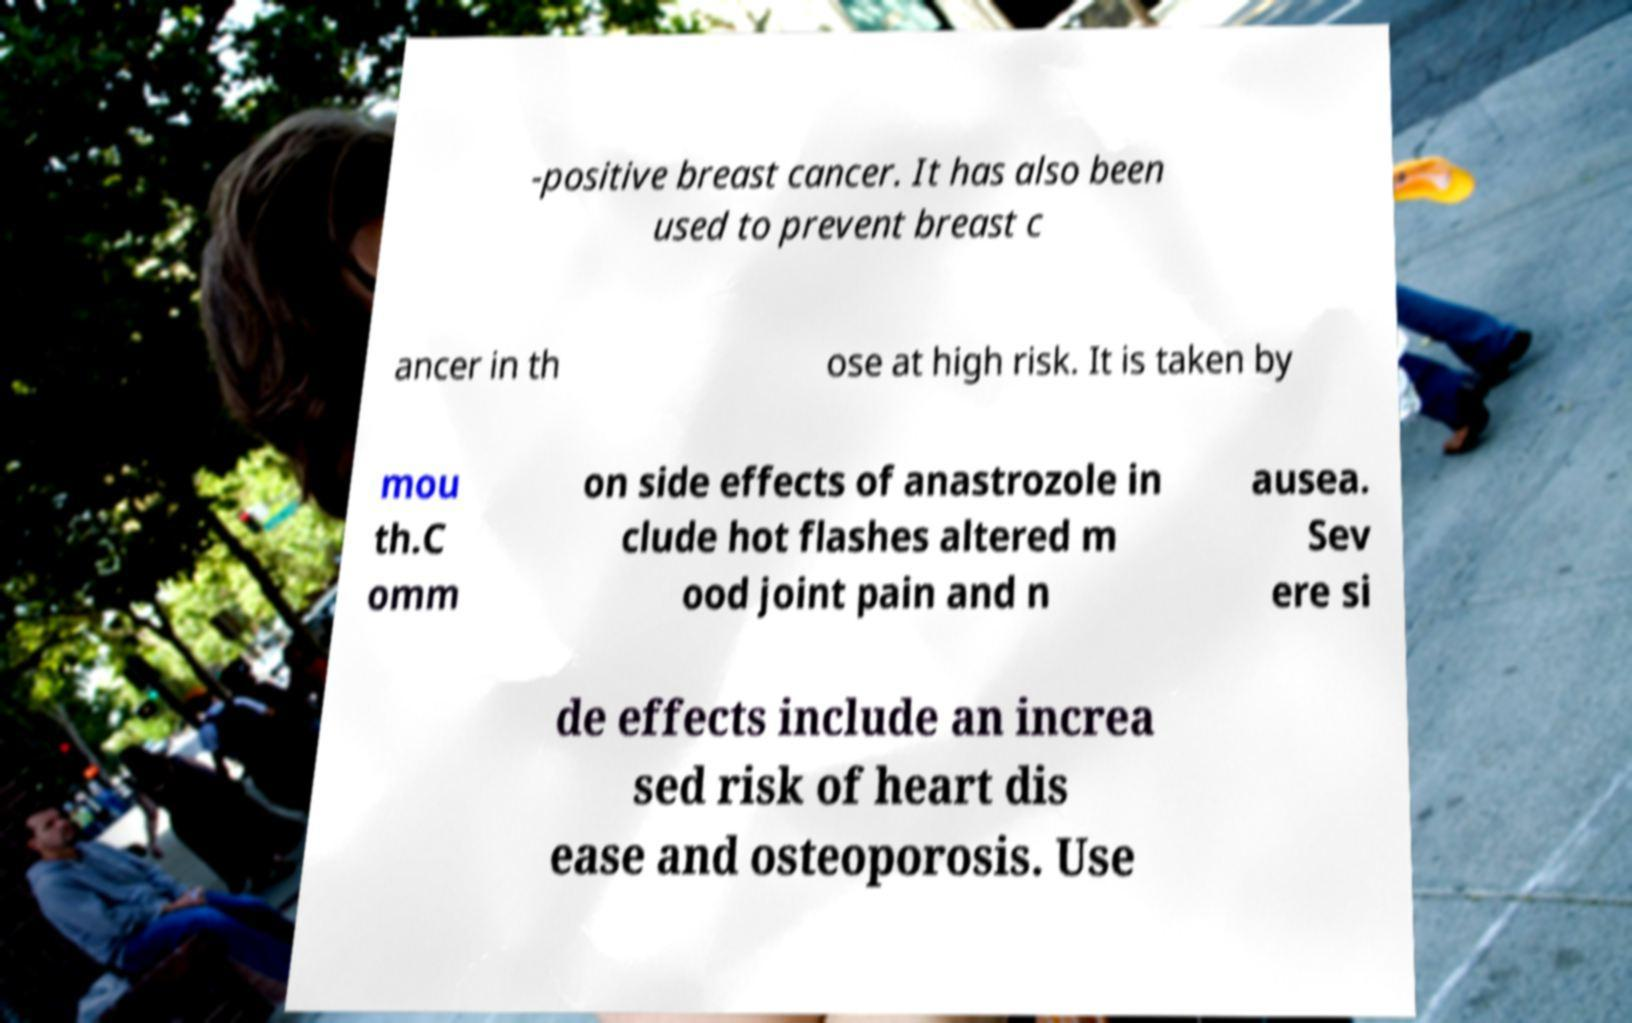I need the written content from this picture converted into text. Can you do that? -positive breast cancer. It has also been used to prevent breast c ancer in th ose at high risk. It is taken by mou th.C omm on side effects of anastrozole in clude hot flashes altered m ood joint pain and n ausea. Sev ere si de effects include an increa sed risk of heart dis ease and osteoporosis. Use 